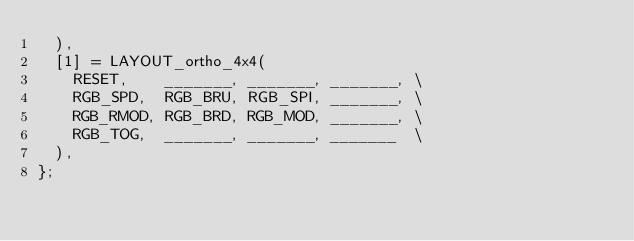Convert code to text. <code><loc_0><loc_0><loc_500><loc_500><_C_>	),
	[1] = LAYOUT_ortho_4x4(
		RESET,    _______, _______, _______, \
		RGB_SPD,  RGB_BRU, RGB_SPI, _______, \
		RGB_RMOD, RGB_BRD, RGB_MOD, _______, \
		RGB_TOG,  _______, _______, _______  \
	),
};</code> 